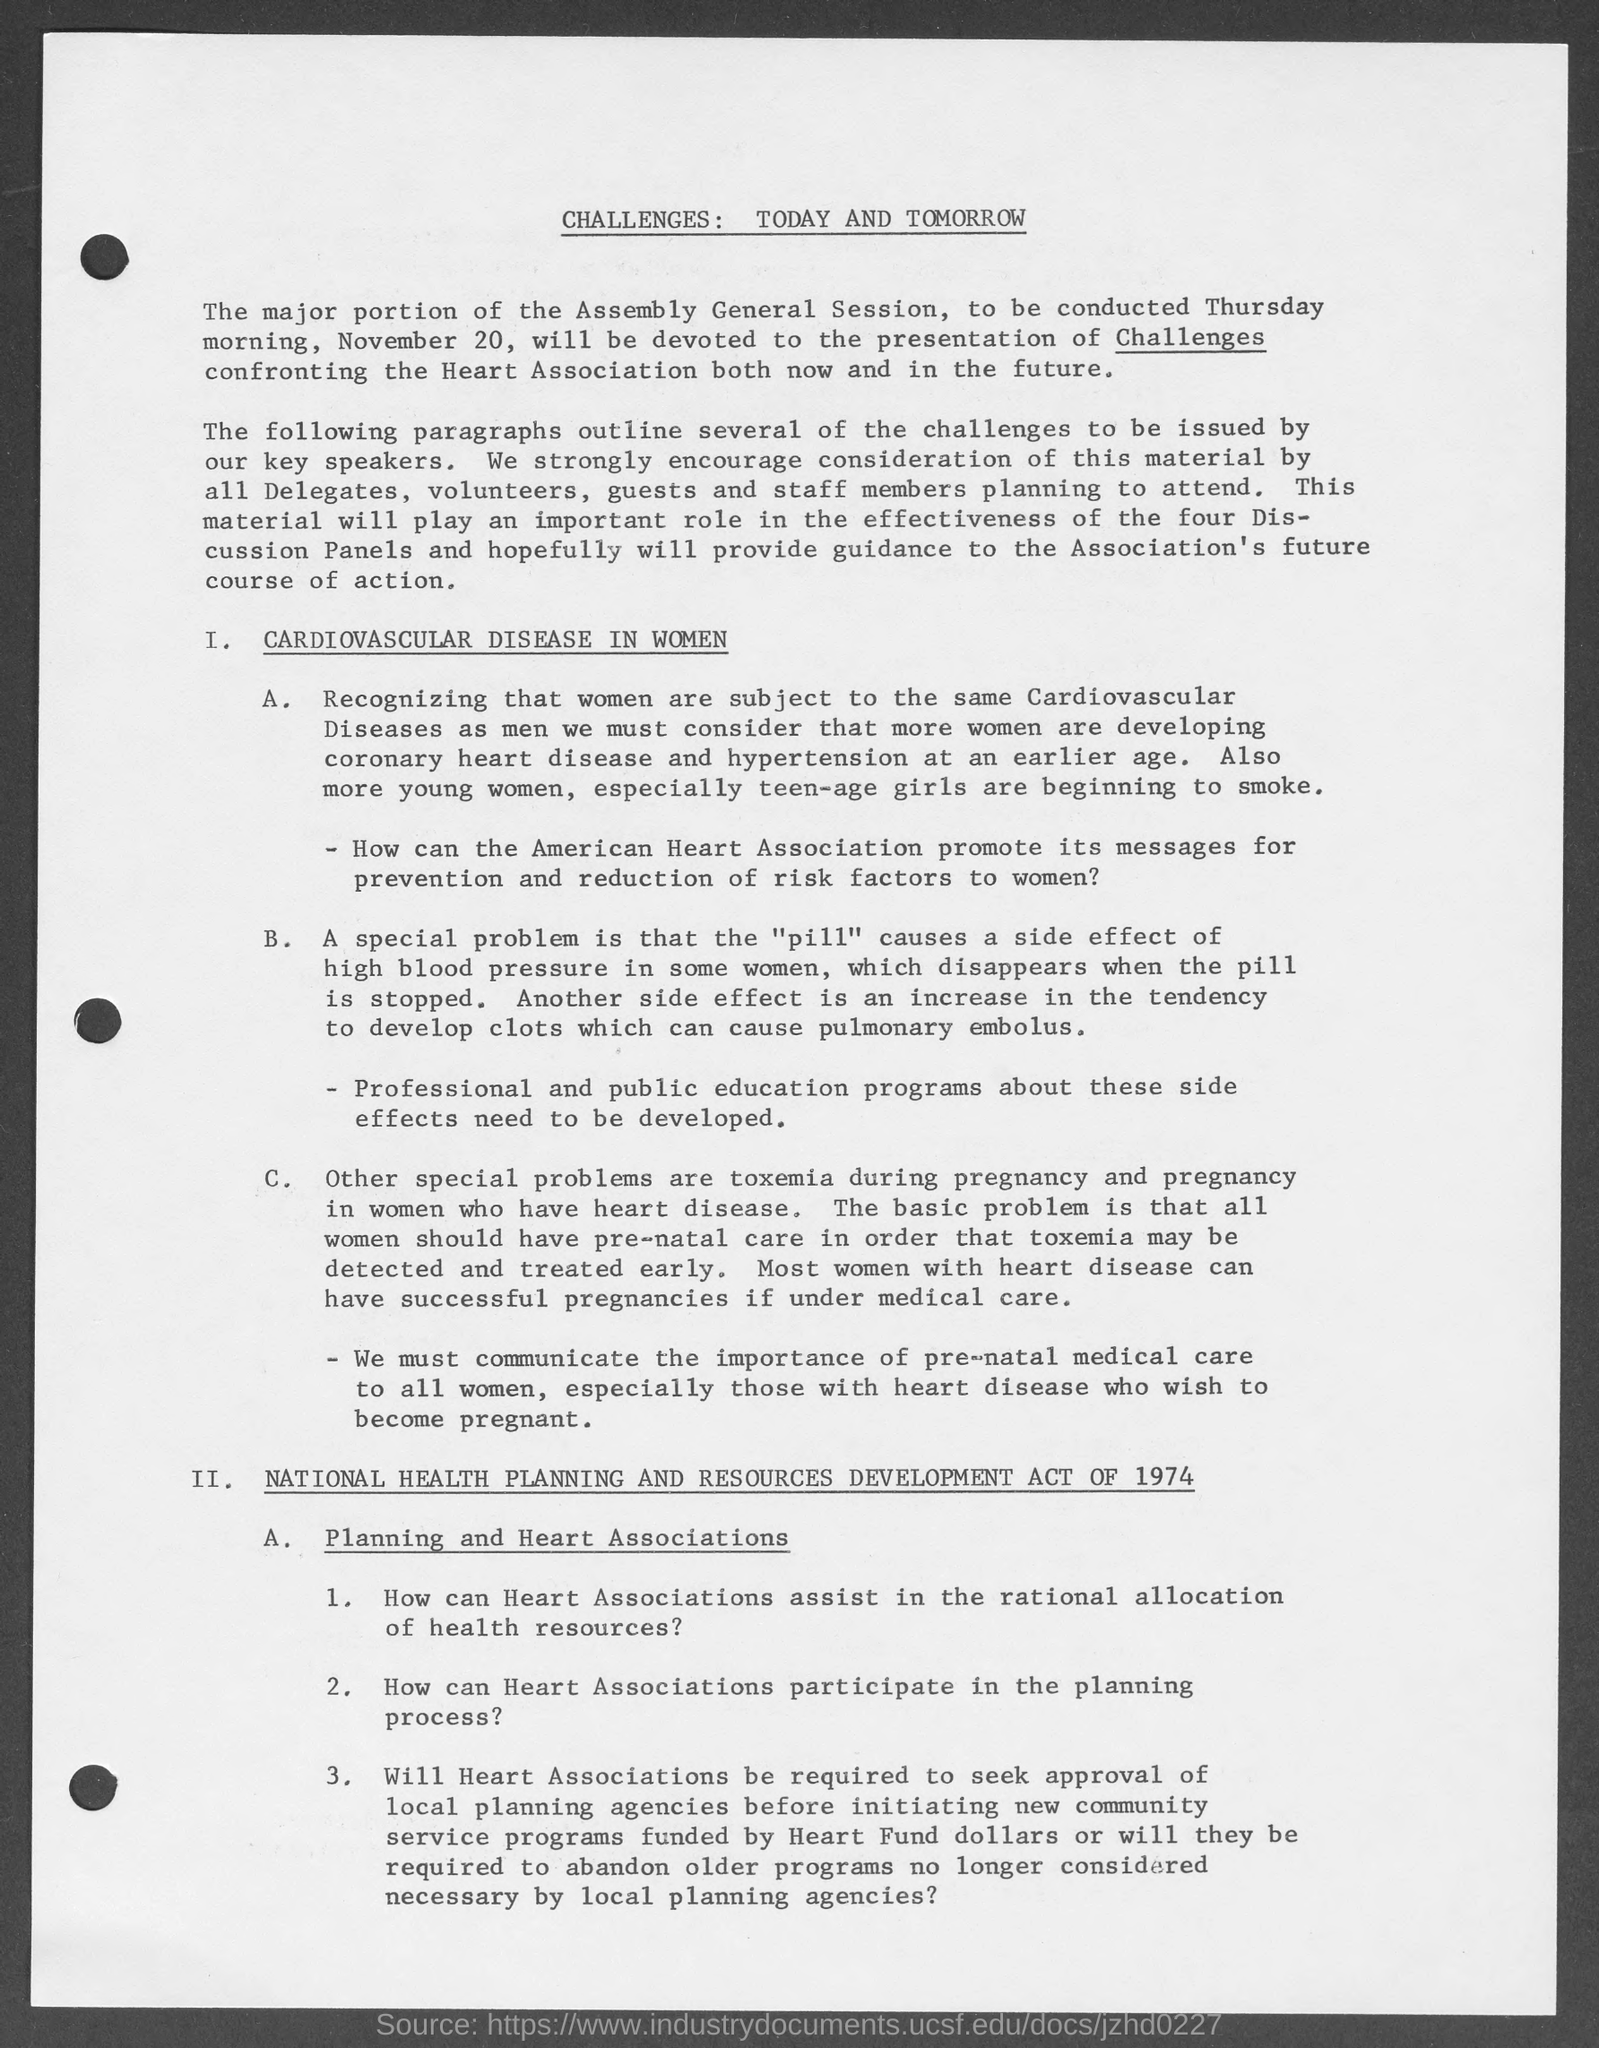Are there specific challenges mentioned in the document related to pre-natal care and heart disease? Yes, the document addresses the challenge of toxemia during pregnancy in women who have heart disease. It underscores the importance of pre-natal care to detect and treat toxemia early. The goal is to enable most women with heart disease to have successful pregnancies with the right medical care and emphasizes the need to communicate the importance of this to women, especially those with heart disease who wish to become pregnant. 